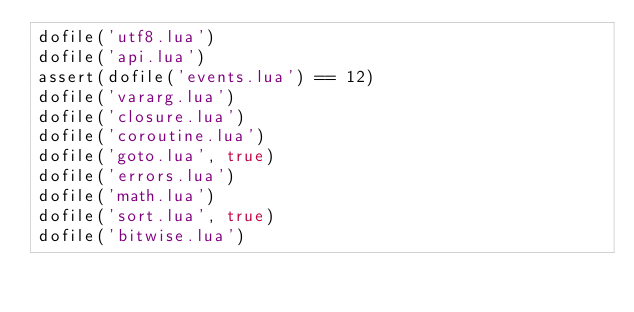<code> <loc_0><loc_0><loc_500><loc_500><_Lua_>dofile('utf8.lua')
dofile('api.lua')
assert(dofile('events.lua') == 12)
dofile('vararg.lua')
dofile('closure.lua')
dofile('coroutine.lua')
dofile('goto.lua', true)
dofile('errors.lua')
dofile('math.lua')
dofile('sort.lua', true)
dofile('bitwise.lua')</code> 